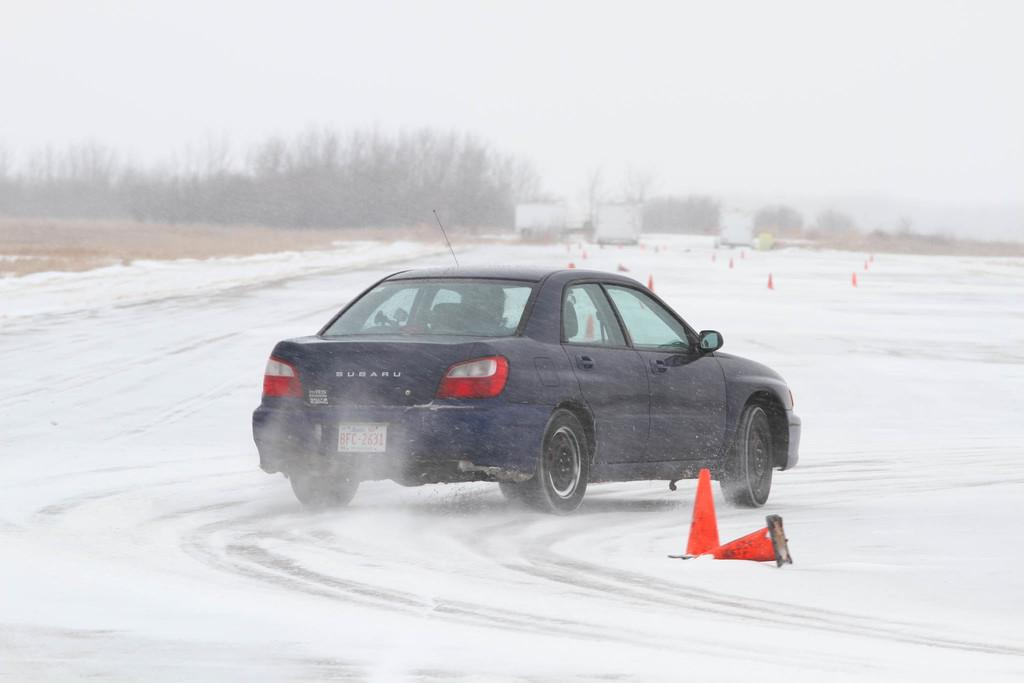What is the main subject of the image? The main subject of the image is a car. What is the car doing in the image? The car is moving on a snow road. What can be seen on the left side of the image? There are trees on the left side of the image. What is visible at the top of the image? The sky is visible at the top of the image. How does the sky appear in the image? The sky appears to be foggy in the image. Can you tell me how many geese are flying in the image? There are no geese present in the image; it features a car moving on a snow road with trees and a foggy sky. What type of stitch is used to sew the car's tires in the image? The image does not show any stitching or sewing related to the car's tires; it is a photograph of a car moving on a snow road. 